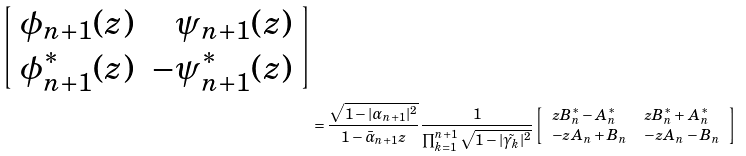Convert formula to latex. <formula><loc_0><loc_0><loc_500><loc_500>{ \left [ \begin{array} { c r } \phi _ { n + 1 } ( z ) & \psi _ { n + 1 } ( z ) \\ \phi _ { n + 1 } ^ { * } ( z ) & - \psi _ { n + 1 } ^ { * } ( z ) \end{array} \right ] } \\ & = \frac { \sqrt { 1 - | \alpha _ { n + 1 } | ^ { 2 } } } { 1 - \bar { \alpha } _ { n + 1 } z } \frac { 1 } { \prod _ { k = 1 } ^ { n + 1 } \sqrt { 1 - | \tilde { \gamma _ { k } } | ^ { 2 } } } \left [ \begin{array} { l l } z B _ { n } ^ { * } - A _ { n } ^ { * } & z B _ { n } ^ { * } + A _ { n } ^ { * } \\ - z A _ { n } + B _ { n } & - z A _ { n } - B _ { n } \end{array} \right ]</formula> 